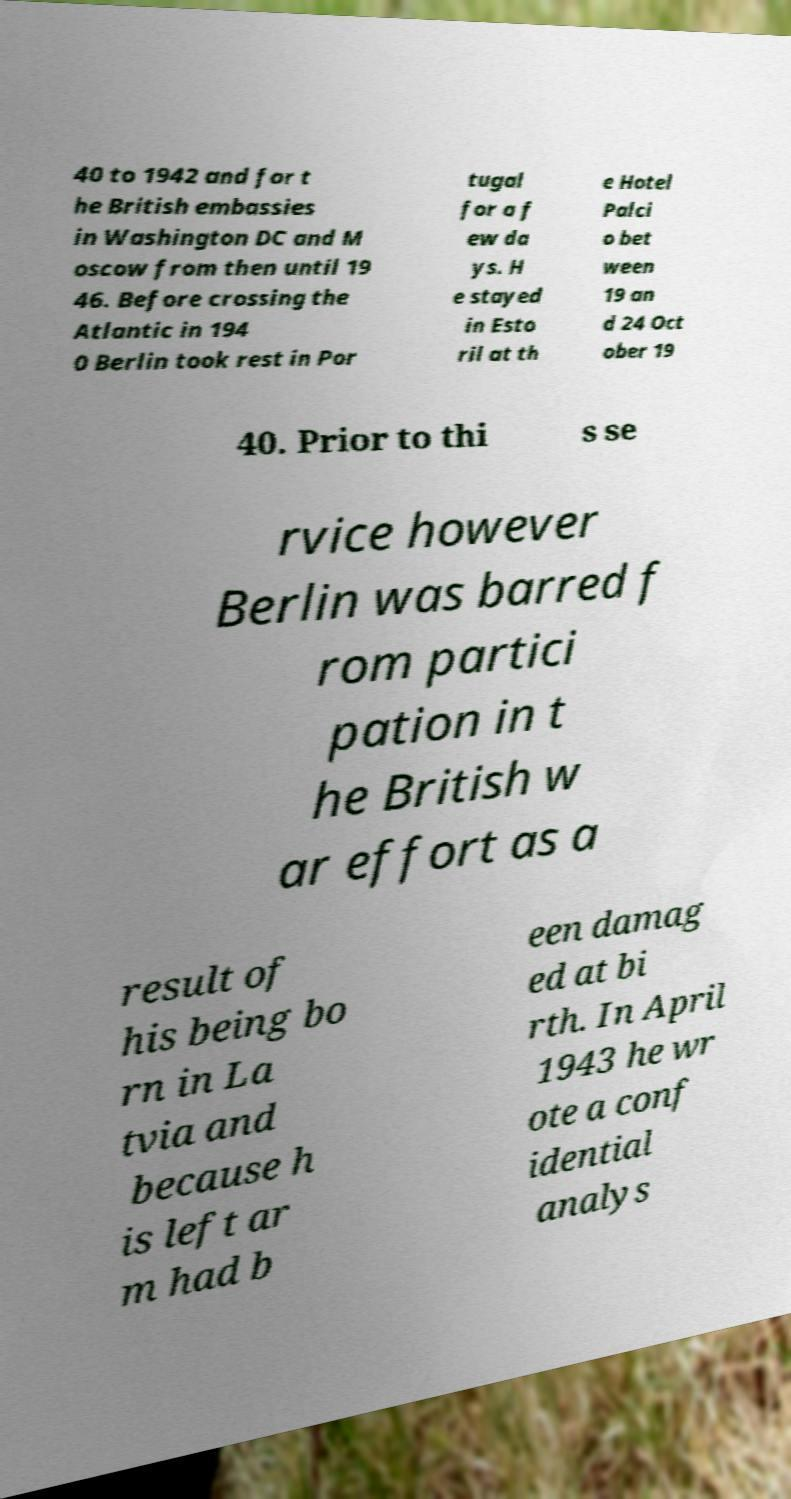Please read and relay the text visible in this image. What does it say? 40 to 1942 and for t he British embassies in Washington DC and M oscow from then until 19 46. Before crossing the Atlantic in 194 0 Berlin took rest in Por tugal for a f ew da ys. H e stayed in Esto ril at th e Hotel Palci o bet ween 19 an d 24 Oct ober 19 40. Prior to thi s se rvice however Berlin was barred f rom partici pation in t he British w ar effort as a result of his being bo rn in La tvia and because h is left ar m had b een damag ed at bi rth. In April 1943 he wr ote a conf idential analys 